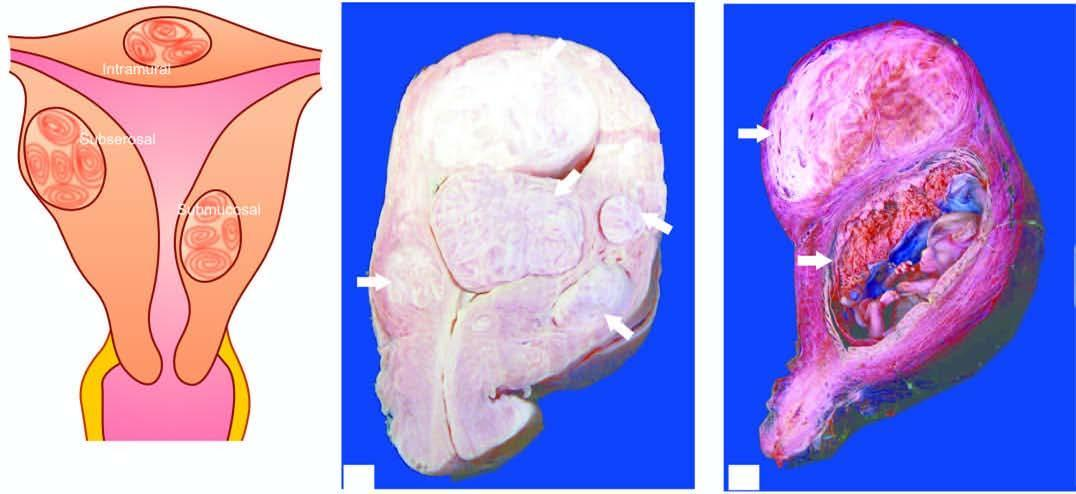what does the opened up uterine cavity show?
Answer the question using a single word or phrase. An intrauterine gestation sac with placenta having grey-white whorled pattern 